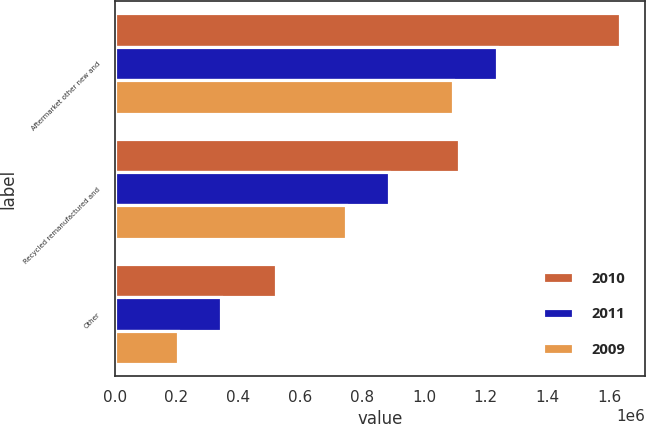<chart> <loc_0><loc_0><loc_500><loc_500><stacked_bar_chart><ecel><fcel>Aftermarket other new and<fcel>Recycled remanufactured and<fcel>Other<nl><fcel>2010<fcel>1.634e+06<fcel>1.11509e+06<fcel>520771<nl><fcel>2011<fcel>1.23681e+06<fcel>888320<fcel>344755<nl><fcel>2009<fcel>1.09316e+06<fcel>749012<fcel>205773<nl></chart> 